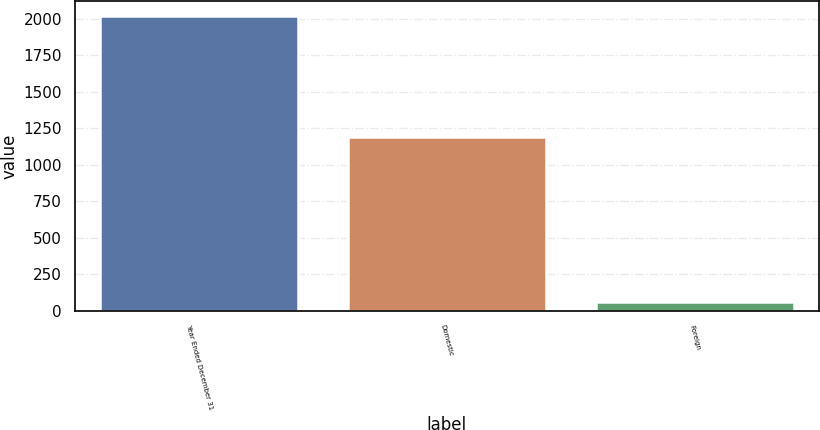Convert chart to OTSL. <chart><loc_0><loc_0><loc_500><loc_500><bar_chart><fcel>Year Ended December 31<fcel>Domestic<fcel>Foreign<nl><fcel>2016<fcel>1190.7<fcel>60.3<nl></chart> 